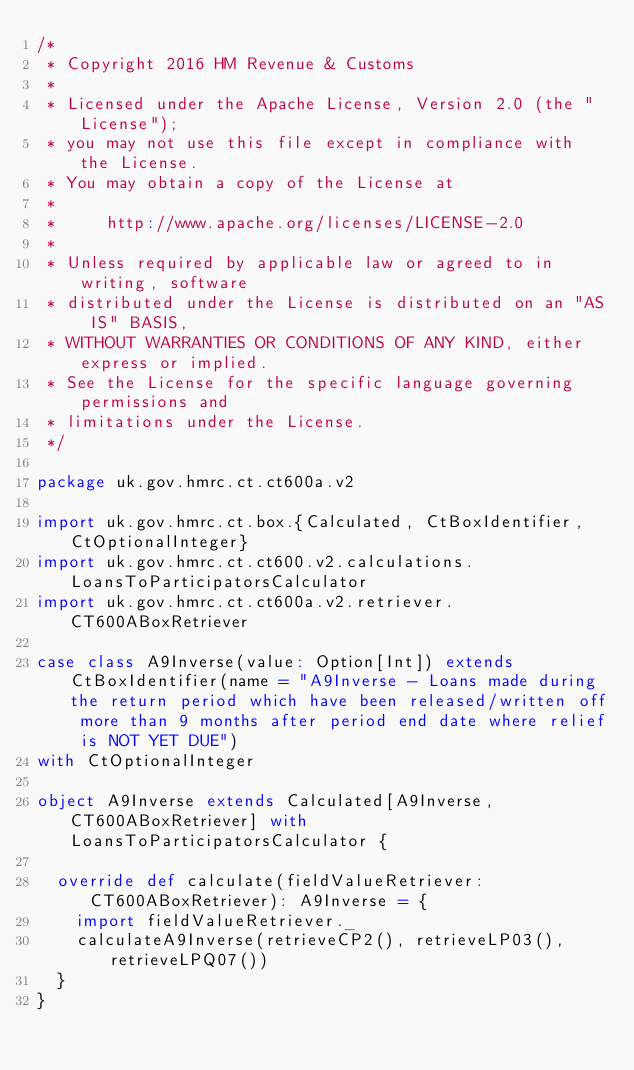<code> <loc_0><loc_0><loc_500><loc_500><_Scala_>/*
 * Copyright 2016 HM Revenue & Customs
 *
 * Licensed under the Apache License, Version 2.0 (the "License");
 * you may not use this file except in compliance with the License.
 * You may obtain a copy of the License at
 *
 *     http://www.apache.org/licenses/LICENSE-2.0
 *
 * Unless required by applicable law or agreed to in writing, software
 * distributed under the License is distributed on an "AS IS" BASIS,
 * WITHOUT WARRANTIES OR CONDITIONS OF ANY KIND, either express or implied.
 * See the License for the specific language governing permissions and
 * limitations under the License.
 */

package uk.gov.hmrc.ct.ct600a.v2

import uk.gov.hmrc.ct.box.{Calculated, CtBoxIdentifier, CtOptionalInteger}
import uk.gov.hmrc.ct.ct600.v2.calculations.LoansToParticipatorsCalculator
import uk.gov.hmrc.ct.ct600a.v2.retriever.CT600ABoxRetriever

case class A9Inverse(value: Option[Int]) extends CtBoxIdentifier(name = "A9Inverse - Loans made during the return period which have been released/written off more than 9 months after period end date where relief is NOT YET DUE")
with CtOptionalInteger

object A9Inverse extends Calculated[A9Inverse, CT600ABoxRetriever] with LoansToParticipatorsCalculator {

  override def calculate(fieldValueRetriever: CT600ABoxRetriever): A9Inverse = {
    import fieldValueRetriever._
    calculateA9Inverse(retrieveCP2(), retrieveLP03(), retrieveLPQ07())
  }
}
</code> 